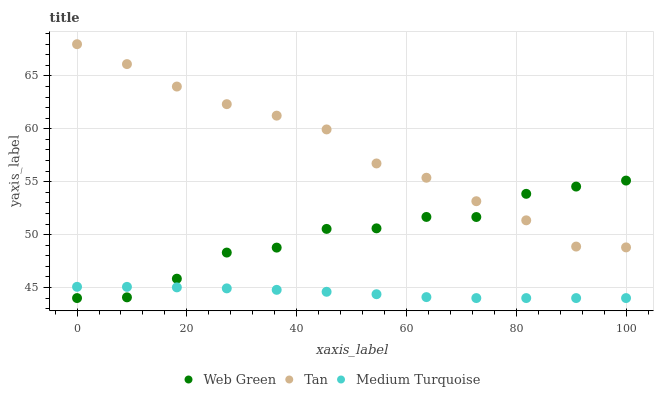Does Medium Turquoise have the minimum area under the curve?
Answer yes or no. Yes. Does Tan have the maximum area under the curve?
Answer yes or no. Yes. Does Web Green have the minimum area under the curve?
Answer yes or no. No. Does Web Green have the maximum area under the curve?
Answer yes or no. No. Is Medium Turquoise the smoothest?
Answer yes or no. Yes. Is Web Green the roughest?
Answer yes or no. Yes. Is Web Green the smoothest?
Answer yes or no. No. Is Medium Turquoise the roughest?
Answer yes or no. No. Does Medium Turquoise have the lowest value?
Answer yes or no. Yes. Does Tan have the highest value?
Answer yes or no. Yes. Does Web Green have the highest value?
Answer yes or no. No. Is Medium Turquoise less than Tan?
Answer yes or no. Yes. Is Tan greater than Medium Turquoise?
Answer yes or no. Yes. Does Web Green intersect Medium Turquoise?
Answer yes or no. Yes. Is Web Green less than Medium Turquoise?
Answer yes or no. No. Is Web Green greater than Medium Turquoise?
Answer yes or no. No. Does Medium Turquoise intersect Tan?
Answer yes or no. No. 